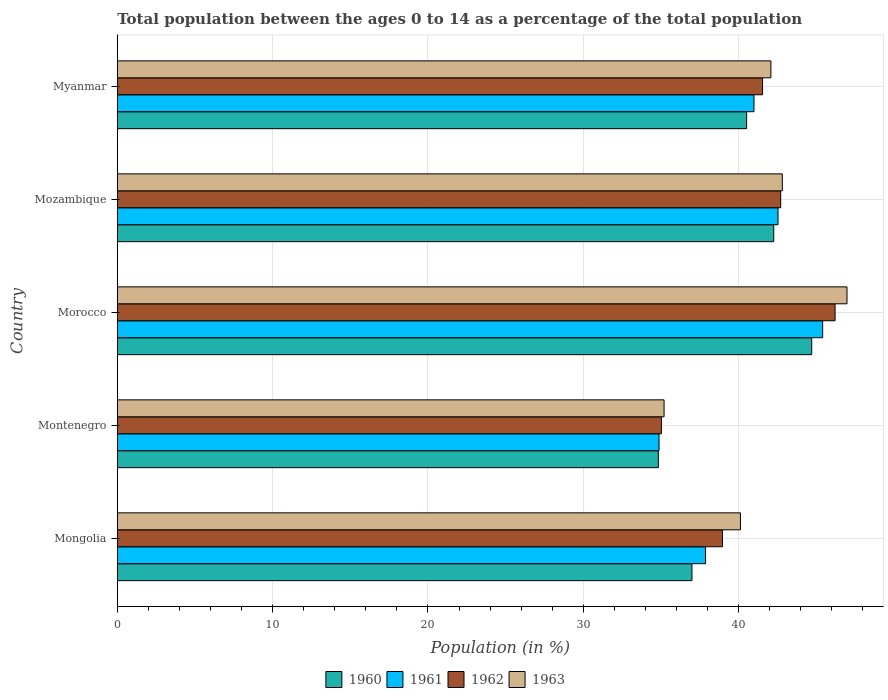How many different coloured bars are there?
Provide a short and direct response. 4. Are the number of bars per tick equal to the number of legend labels?
Give a very brief answer. Yes. Are the number of bars on each tick of the Y-axis equal?
Provide a succinct answer. Yes. What is the label of the 3rd group of bars from the top?
Make the answer very short. Morocco. In how many cases, is the number of bars for a given country not equal to the number of legend labels?
Offer a very short reply. 0. What is the percentage of the population ages 0 to 14 in 1962 in Mozambique?
Your answer should be very brief. 42.71. Across all countries, what is the maximum percentage of the population ages 0 to 14 in 1960?
Your response must be concise. 44.71. Across all countries, what is the minimum percentage of the population ages 0 to 14 in 1961?
Ensure brevity in your answer.  34.88. In which country was the percentage of the population ages 0 to 14 in 1963 maximum?
Keep it short and to the point. Morocco. In which country was the percentage of the population ages 0 to 14 in 1963 minimum?
Your response must be concise. Montenegro. What is the total percentage of the population ages 0 to 14 in 1962 in the graph?
Provide a succinct answer. 204.45. What is the difference between the percentage of the population ages 0 to 14 in 1963 in Mongolia and that in Montenegro?
Your response must be concise. 4.92. What is the difference between the percentage of the population ages 0 to 14 in 1960 in Mozambique and the percentage of the population ages 0 to 14 in 1961 in Montenegro?
Offer a terse response. 7.38. What is the average percentage of the population ages 0 to 14 in 1960 per country?
Provide a succinct answer. 39.86. What is the difference between the percentage of the population ages 0 to 14 in 1963 and percentage of the population ages 0 to 14 in 1961 in Mozambique?
Provide a short and direct response. 0.28. What is the ratio of the percentage of the population ages 0 to 14 in 1963 in Morocco to that in Myanmar?
Provide a succinct answer. 1.12. Is the percentage of the population ages 0 to 14 in 1962 in Mongolia less than that in Montenegro?
Make the answer very short. No. Is the difference between the percentage of the population ages 0 to 14 in 1963 in Montenegro and Myanmar greater than the difference between the percentage of the population ages 0 to 14 in 1961 in Montenegro and Myanmar?
Provide a succinct answer. No. What is the difference between the highest and the second highest percentage of the population ages 0 to 14 in 1962?
Provide a short and direct response. 3.5. What is the difference between the highest and the lowest percentage of the population ages 0 to 14 in 1961?
Provide a succinct answer. 10.53. Is the sum of the percentage of the population ages 0 to 14 in 1962 in Mozambique and Myanmar greater than the maximum percentage of the population ages 0 to 14 in 1963 across all countries?
Your response must be concise. Yes. What does the 4th bar from the top in Mongolia represents?
Your response must be concise. 1960. Is it the case that in every country, the sum of the percentage of the population ages 0 to 14 in 1960 and percentage of the population ages 0 to 14 in 1962 is greater than the percentage of the population ages 0 to 14 in 1963?
Provide a succinct answer. Yes. How many countries are there in the graph?
Keep it short and to the point. 5. What is the difference between two consecutive major ticks on the X-axis?
Provide a short and direct response. 10. Are the values on the major ticks of X-axis written in scientific E-notation?
Offer a very short reply. No. Where does the legend appear in the graph?
Ensure brevity in your answer.  Bottom center. What is the title of the graph?
Your response must be concise. Total population between the ages 0 to 14 as a percentage of the total population. Does "1987" appear as one of the legend labels in the graph?
Keep it short and to the point. No. What is the label or title of the Y-axis?
Provide a short and direct response. Country. What is the Population (in %) in 1960 in Mongolia?
Your answer should be compact. 37. What is the Population (in %) in 1961 in Mongolia?
Give a very brief answer. 37.87. What is the Population (in %) in 1962 in Mongolia?
Make the answer very short. 38.96. What is the Population (in %) of 1963 in Mongolia?
Provide a short and direct response. 40.12. What is the Population (in %) in 1960 in Montenegro?
Offer a very short reply. 34.83. What is the Population (in %) of 1961 in Montenegro?
Ensure brevity in your answer.  34.88. What is the Population (in %) in 1962 in Montenegro?
Your answer should be compact. 35.03. What is the Population (in %) in 1963 in Montenegro?
Your answer should be very brief. 35.2. What is the Population (in %) of 1960 in Morocco?
Make the answer very short. 44.71. What is the Population (in %) in 1961 in Morocco?
Your response must be concise. 45.41. What is the Population (in %) of 1962 in Morocco?
Provide a succinct answer. 46.21. What is the Population (in %) in 1963 in Morocco?
Give a very brief answer. 46.98. What is the Population (in %) in 1960 in Mozambique?
Offer a very short reply. 42.26. What is the Population (in %) in 1961 in Mozambique?
Your answer should be compact. 42.53. What is the Population (in %) of 1962 in Mozambique?
Your response must be concise. 42.71. What is the Population (in %) of 1963 in Mozambique?
Give a very brief answer. 42.81. What is the Population (in %) in 1960 in Myanmar?
Provide a succinct answer. 40.52. What is the Population (in %) in 1961 in Myanmar?
Keep it short and to the point. 40.99. What is the Population (in %) in 1962 in Myanmar?
Offer a very short reply. 41.54. What is the Population (in %) of 1963 in Myanmar?
Your response must be concise. 42.08. Across all countries, what is the maximum Population (in %) of 1960?
Keep it short and to the point. 44.71. Across all countries, what is the maximum Population (in %) of 1961?
Provide a short and direct response. 45.41. Across all countries, what is the maximum Population (in %) in 1962?
Provide a succinct answer. 46.21. Across all countries, what is the maximum Population (in %) of 1963?
Your answer should be very brief. 46.98. Across all countries, what is the minimum Population (in %) in 1960?
Make the answer very short. 34.83. Across all countries, what is the minimum Population (in %) in 1961?
Ensure brevity in your answer.  34.88. Across all countries, what is the minimum Population (in %) of 1962?
Provide a succinct answer. 35.03. Across all countries, what is the minimum Population (in %) in 1963?
Provide a short and direct response. 35.2. What is the total Population (in %) of 1960 in the graph?
Make the answer very short. 199.31. What is the total Population (in %) of 1961 in the graph?
Offer a very short reply. 201.68. What is the total Population (in %) of 1962 in the graph?
Provide a short and direct response. 204.45. What is the total Population (in %) in 1963 in the graph?
Your answer should be compact. 207.19. What is the difference between the Population (in %) in 1960 in Mongolia and that in Montenegro?
Keep it short and to the point. 2.17. What is the difference between the Population (in %) in 1961 in Mongolia and that in Montenegro?
Provide a succinct answer. 2.99. What is the difference between the Population (in %) in 1962 in Mongolia and that in Montenegro?
Provide a succinct answer. 3.93. What is the difference between the Population (in %) in 1963 in Mongolia and that in Montenegro?
Make the answer very short. 4.92. What is the difference between the Population (in %) of 1960 in Mongolia and that in Morocco?
Your answer should be compact. -7.71. What is the difference between the Population (in %) in 1961 in Mongolia and that in Morocco?
Make the answer very short. -7.54. What is the difference between the Population (in %) in 1962 in Mongolia and that in Morocco?
Your answer should be compact. -7.25. What is the difference between the Population (in %) in 1963 in Mongolia and that in Morocco?
Provide a succinct answer. -6.86. What is the difference between the Population (in %) of 1960 in Mongolia and that in Mozambique?
Your answer should be compact. -5.26. What is the difference between the Population (in %) of 1961 in Mongolia and that in Mozambique?
Provide a short and direct response. -4.67. What is the difference between the Population (in %) of 1962 in Mongolia and that in Mozambique?
Provide a succinct answer. -3.75. What is the difference between the Population (in %) of 1963 in Mongolia and that in Mozambique?
Offer a very short reply. -2.7. What is the difference between the Population (in %) in 1960 in Mongolia and that in Myanmar?
Your answer should be compact. -3.52. What is the difference between the Population (in %) of 1961 in Mongolia and that in Myanmar?
Make the answer very short. -3.12. What is the difference between the Population (in %) in 1962 in Mongolia and that in Myanmar?
Keep it short and to the point. -2.58. What is the difference between the Population (in %) of 1963 in Mongolia and that in Myanmar?
Offer a terse response. -1.96. What is the difference between the Population (in %) of 1960 in Montenegro and that in Morocco?
Provide a short and direct response. -9.87. What is the difference between the Population (in %) in 1961 in Montenegro and that in Morocco?
Offer a terse response. -10.53. What is the difference between the Population (in %) in 1962 in Montenegro and that in Morocco?
Provide a succinct answer. -11.18. What is the difference between the Population (in %) in 1963 in Montenegro and that in Morocco?
Offer a terse response. -11.78. What is the difference between the Population (in %) in 1960 in Montenegro and that in Mozambique?
Give a very brief answer. -7.43. What is the difference between the Population (in %) of 1961 in Montenegro and that in Mozambique?
Your response must be concise. -7.66. What is the difference between the Population (in %) of 1962 in Montenegro and that in Mozambique?
Your answer should be very brief. -7.68. What is the difference between the Population (in %) of 1963 in Montenegro and that in Mozambique?
Make the answer very short. -7.61. What is the difference between the Population (in %) in 1960 in Montenegro and that in Myanmar?
Make the answer very short. -5.68. What is the difference between the Population (in %) in 1961 in Montenegro and that in Myanmar?
Your response must be concise. -6.11. What is the difference between the Population (in %) in 1962 in Montenegro and that in Myanmar?
Keep it short and to the point. -6.51. What is the difference between the Population (in %) in 1963 in Montenegro and that in Myanmar?
Your answer should be very brief. -6.88. What is the difference between the Population (in %) in 1960 in Morocco and that in Mozambique?
Offer a very short reply. 2.44. What is the difference between the Population (in %) of 1961 in Morocco and that in Mozambique?
Your answer should be compact. 2.88. What is the difference between the Population (in %) of 1962 in Morocco and that in Mozambique?
Your answer should be very brief. 3.5. What is the difference between the Population (in %) of 1963 in Morocco and that in Mozambique?
Offer a terse response. 4.16. What is the difference between the Population (in %) of 1960 in Morocco and that in Myanmar?
Keep it short and to the point. 4.19. What is the difference between the Population (in %) in 1961 in Morocco and that in Myanmar?
Give a very brief answer. 4.42. What is the difference between the Population (in %) of 1962 in Morocco and that in Myanmar?
Make the answer very short. 4.67. What is the difference between the Population (in %) in 1963 in Morocco and that in Myanmar?
Keep it short and to the point. 4.9. What is the difference between the Population (in %) in 1960 in Mozambique and that in Myanmar?
Ensure brevity in your answer.  1.75. What is the difference between the Population (in %) of 1961 in Mozambique and that in Myanmar?
Make the answer very short. 1.54. What is the difference between the Population (in %) of 1962 in Mozambique and that in Myanmar?
Your answer should be very brief. 1.17. What is the difference between the Population (in %) in 1963 in Mozambique and that in Myanmar?
Give a very brief answer. 0.74. What is the difference between the Population (in %) of 1960 in Mongolia and the Population (in %) of 1961 in Montenegro?
Your answer should be compact. 2.12. What is the difference between the Population (in %) of 1960 in Mongolia and the Population (in %) of 1962 in Montenegro?
Give a very brief answer. 1.97. What is the difference between the Population (in %) in 1960 in Mongolia and the Population (in %) in 1963 in Montenegro?
Make the answer very short. 1.8. What is the difference between the Population (in %) in 1961 in Mongolia and the Population (in %) in 1962 in Montenegro?
Your answer should be compact. 2.84. What is the difference between the Population (in %) in 1961 in Mongolia and the Population (in %) in 1963 in Montenegro?
Offer a very short reply. 2.67. What is the difference between the Population (in %) in 1962 in Mongolia and the Population (in %) in 1963 in Montenegro?
Your response must be concise. 3.76. What is the difference between the Population (in %) in 1960 in Mongolia and the Population (in %) in 1961 in Morocco?
Make the answer very short. -8.41. What is the difference between the Population (in %) of 1960 in Mongolia and the Population (in %) of 1962 in Morocco?
Offer a terse response. -9.21. What is the difference between the Population (in %) in 1960 in Mongolia and the Population (in %) in 1963 in Morocco?
Keep it short and to the point. -9.98. What is the difference between the Population (in %) in 1961 in Mongolia and the Population (in %) in 1962 in Morocco?
Your answer should be compact. -8.34. What is the difference between the Population (in %) in 1961 in Mongolia and the Population (in %) in 1963 in Morocco?
Ensure brevity in your answer.  -9.11. What is the difference between the Population (in %) in 1962 in Mongolia and the Population (in %) in 1963 in Morocco?
Make the answer very short. -8.02. What is the difference between the Population (in %) in 1960 in Mongolia and the Population (in %) in 1961 in Mozambique?
Ensure brevity in your answer.  -5.54. What is the difference between the Population (in %) in 1960 in Mongolia and the Population (in %) in 1962 in Mozambique?
Your answer should be compact. -5.71. What is the difference between the Population (in %) of 1960 in Mongolia and the Population (in %) of 1963 in Mozambique?
Offer a very short reply. -5.82. What is the difference between the Population (in %) in 1961 in Mongolia and the Population (in %) in 1962 in Mozambique?
Your answer should be very brief. -4.84. What is the difference between the Population (in %) in 1961 in Mongolia and the Population (in %) in 1963 in Mozambique?
Make the answer very short. -4.95. What is the difference between the Population (in %) of 1962 in Mongolia and the Population (in %) of 1963 in Mozambique?
Provide a short and direct response. -3.86. What is the difference between the Population (in %) of 1960 in Mongolia and the Population (in %) of 1961 in Myanmar?
Give a very brief answer. -3.99. What is the difference between the Population (in %) in 1960 in Mongolia and the Population (in %) in 1962 in Myanmar?
Offer a very short reply. -4.55. What is the difference between the Population (in %) of 1960 in Mongolia and the Population (in %) of 1963 in Myanmar?
Keep it short and to the point. -5.08. What is the difference between the Population (in %) of 1961 in Mongolia and the Population (in %) of 1962 in Myanmar?
Your answer should be very brief. -3.68. What is the difference between the Population (in %) in 1961 in Mongolia and the Population (in %) in 1963 in Myanmar?
Ensure brevity in your answer.  -4.21. What is the difference between the Population (in %) of 1962 in Mongolia and the Population (in %) of 1963 in Myanmar?
Give a very brief answer. -3.12. What is the difference between the Population (in %) in 1960 in Montenegro and the Population (in %) in 1961 in Morocco?
Your answer should be very brief. -10.58. What is the difference between the Population (in %) in 1960 in Montenegro and the Population (in %) in 1962 in Morocco?
Make the answer very short. -11.38. What is the difference between the Population (in %) of 1960 in Montenegro and the Population (in %) of 1963 in Morocco?
Your answer should be very brief. -12.15. What is the difference between the Population (in %) of 1961 in Montenegro and the Population (in %) of 1962 in Morocco?
Give a very brief answer. -11.33. What is the difference between the Population (in %) of 1961 in Montenegro and the Population (in %) of 1963 in Morocco?
Your answer should be compact. -12.1. What is the difference between the Population (in %) in 1962 in Montenegro and the Population (in %) in 1963 in Morocco?
Keep it short and to the point. -11.95. What is the difference between the Population (in %) in 1960 in Montenegro and the Population (in %) in 1961 in Mozambique?
Keep it short and to the point. -7.7. What is the difference between the Population (in %) in 1960 in Montenegro and the Population (in %) in 1962 in Mozambique?
Offer a very short reply. -7.88. What is the difference between the Population (in %) of 1960 in Montenegro and the Population (in %) of 1963 in Mozambique?
Ensure brevity in your answer.  -7.98. What is the difference between the Population (in %) in 1961 in Montenegro and the Population (in %) in 1962 in Mozambique?
Keep it short and to the point. -7.83. What is the difference between the Population (in %) in 1961 in Montenegro and the Population (in %) in 1963 in Mozambique?
Your answer should be compact. -7.94. What is the difference between the Population (in %) in 1962 in Montenegro and the Population (in %) in 1963 in Mozambique?
Your response must be concise. -7.78. What is the difference between the Population (in %) in 1960 in Montenegro and the Population (in %) in 1961 in Myanmar?
Make the answer very short. -6.16. What is the difference between the Population (in %) in 1960 in Montenegro and the Population (in %) in 1962 in Myanmar?
Offer a very short reply. -6.71. What is the difference between the Population (in %) in 1960 in Montenegro and the Population (in %) in 1963 in Myanmar?
Ensure brevity in your answer.  -7.25. What is the difference between the Population (in %) of 1961 in Montenegro and the Population (in %) of 1962 in Myanmar?
Keep it short and to the point. -6.67. What is the difference between the Population (in %) in 1961 in Montenegro and the Population (in %) in 1963 in Myanmar?
Offer a terse response. -7.2. What is the difference between the Population (in %) in 1962 in Montenegro and the Population (in %) in 1963 in Myanmar?
Provide a succinct answer. -7.05. What is the difference between the Population (in %) of 1960 in Morocco and the Population (in %) of 1961 in Mozambique?
Ensure brevity in your answer.  2.17. What is the difference between the Population (in %) in 1960 in Morocco and the Population (in %) in 1962 in Mozambique?
Make the answer very short. 2. What is the difference between the Population (in %) in 1960 in Morocco and the Population (in %) in 1963 in Mozambique?
Your answer should be compact. 1.89. What is the difference between the Population (in %) of 1961 in Morocco and the Population (in %) of 1962 in Mozambique?
Offer a very short reply. 2.7. What is the difference between the Population (in %) of 1961 in Morocco and the Population (in %) of 1963 in Mozambique?
Ensure brevity in your answer.  2.6. What is the difference between the Population (in %) in 1962 in Morocco and the Population (in %) in 1963 in Mozambique?
Ensure brevity in your answer.  3.4. What is the difference between the Population (in %) in 1960 in Morocco and the Population (in %) in 1961 in Myanmar?
Make the answer very short. 3.72. What is the difference between the Population (in %) in 1960 in Morocco and the Population (in %) in 1962 in Myanmar?
Make the answer very short. 3.16. What is the difference between the Population (in %) in 1960 in Morocco and the Population (in %) in 1963 in Myanmar?
Provide a short and direct response. 2.63. What is the difference between the Population (in %) of 1961 in Morocco and the Population (in %) of 1962 in Myanmar?
Provide a short and direct response. 3.87. What is the difference between the Population (in %) of 1961 in Morocco and the Population (in %) of 1963 in Myanmar?
Offer a terse response. 3.33. What is the difference between the Population (in %) in 1962 in Morocco and the Population (in %) in 1963 in Myanmar?
Your response must be concise. 4.13. What is the difference between the Population (in %) of 1960 in Mozambique and the Population (in %) of 1961 in Myanmar?
Make the answer very short. 1.27. What is the difference between the Population (in %) of 1960 in Mozambique and the Population (in %) of 1962 in Myanmar?
Provide a short and direct response. 0.72. What is the difference between the Population (in %) in 1960 in Mozambique and the Population (in %) in 1963 in Myanmar?
Ensure brevity in your answer.  0.18. What is the difference between the Population (in %) of 1961 in Mozambique and the Population (in %) of 1962 in Myanmar?
Offer a very short reply. 0.99. What is the difference between the Population (in %) of 1961 in Mozambique and the Population (in %) of 1963 in Myanmar?
Your answer should be very brief. 0.46. What is the difference between the Population (in %) of 1962 in Mozambique and the Population (in %) of 1963 in Myanmar?
Give a very brief answer. 0.63. What is the average Population (in %) in 1960 per country?
Your answer should be very brief. 39.86. What is the average Population (in %) in 1961 per country?
Ensure brevity in your answer.  40.34. What is the average Population (in %) of 1962 per country?
Your answer should be very brief. 40.89. What is the average Population (in %) of 1963 per country?
Keep it short and to the point. 41.44. What is the difference between the Population (in %) of 1960 and Population (in %) of 1961 in Mongolia?
Keep it short and to the point. -0.87. What is the difference between the Population (in %) of 1960 and Population (in %) of 1962 in Mongolia?
Provide a short and direct response. -1.96. What is the difference between the Population (in %) of 1960 and Population (in %) of 1963 in Mongolia?
Your response must be concise. -3.12. What is the difference between the Population (in %) in 1961 and Population (in %) in 1962 in Mongolia?
Offer a very short reply. -1.09. What is the difference between the Population (in %) of 1961 and Population (in %) of 1963 in Mongolia?
Keep it short and to the point. -2.25. What is the difference between the Population (in %) in 1962 and Population (in %) in 1963 in Mongolia?
Give a very brief answer. -1.16. What is the difference between the Population (in %) of 1960 and Population (in %) of 1961 in Montenegro?
Give a very brief answer. -0.05. What is the difference between the Population (in %) in 1960 and Population (in %) in 1962 in Montenegro?
Provide a short and direct response. -0.2. What is the difference between the Population (in %) of 1960 and Population (in %) of 1963 in Montenegro?
Provide a succinct answer. -0.37. What is the difference between the Population (in %) in 1961 and Population (in %) in 1962 in Montenegro?
Keep it short and to the point. -0.15. What is the difference between the Population (in %) in 1961 and Population (in %) in 1963 in Montenegro?
Provide a short and direct response. -0.32. What is the difference between the Population (in %) in 1962 and Population (in %) in 1963 in Montenegro?
Give a very brief answer. -0.17. What is the difference between the Population (in %) in 1960 and Population (in %) in 1961 in Morocco?
Provide a succinct answer. -0.71. What is the difference between the Population (in %) of 1960 and Population (in %) of 1962 in Morocco?
Your answer should be very brief. -1.5. What is the difference between the Population (in %) in 1960 and Population (in %) in 1963 in Morocco?
Your response must be concise. -2.27. What is the difference between the Population (in %) in 1961 and Population (in %) in 1962 in Morocco?
Your answer should be compact. -0.8. What is the difference between the Population (in %) in 1961 and Population (in %) in 1963 in Morocco?
Provide a short and direct response. -1.57. What is the difference between the Population (in %) in 1962 and Population (in %) in 1963 in Morocco?
Provide a short and direct response. -0.77. What is the difference between the Population (in %) of 1960 and Population (in %) of 1961 in Mozambique?
Provide a short and direct response. -0.27. What is the difference between the Population (in %) of 1960 and Population (in %) of 1962 in Mozambique?
Provide a short and direct response. -0.45. What is the difference between the Population (in %) in 1960 and Population (in %) in 1963 in Mozambique?
Make the answer very short. -0.55. What is the difference between the Population (in %) in 1961 and Population (in %) in 1962 in Mozambique?
Keep it short and to the point. -0.17. What is the difference between the Population (in %) in 1961 and Population (in %) in 1963 in Mozambique?
Provide a succinct answer. -0.28. What is the difference between the Population (in %) of 1962 and Population (in %) of 1963 in Mozambique?
Make the answer very short. -0.1. What is the difference between the Population (in %) of 1960 and Population (in %) of 1961 in Myanmar?
Give a very brief answer. -0.47. What is the difference between the Population (in %) in 1960 and Population (in %) in 1962 in Myanmar?
Make the answer very short. -1.03. What is the difference between the Population (in %) in 1960 and Population (in %) in 1963 in Myanmar?
Provide a succinct answer. -1.56. What is the difference between the Population (in %) in 1961 and Population (in %) in 1962 in Myanmar?
Ensure brevity in your answer.  -0.55. What is the difference between the Population (in %) in 1961 and Population (in %) in 1963 in Myanmar?
Provide a succinct answer. -1.09. What is the difference between the Population (in %) in 1962 and Population (in %) in 1963 in Myanmar?
Your response must be concise. -0.54. What is the ratio of the Population (in %) in 1960 in Mongolia to that in Montenegro?
Ensure brevity in your answer.  1.06. What is the ratio of the Population (in %) of 1961 in Mongolia to that in Montenegro?
Give a very brief answer. 1.09. What is the ratio of the Population (in %) of 1962 in Mongolia to that in Montenegro?
Keep it short and to the point. 1.11. What is the ratio of the Population (in %) in 1963 in Mongolia to that in Montenegro?
Your response must be concise. 1.14. What is the ratio of the Population (in %) of 1960 in Mongolia to that in Morocco?
Provide a succinct answer. 0.83. What is the ratio of the Population (in %) of 1961 in Mongolia to that in Morocco?
Provide a short and direct response. 0.83. What is the ratio of the Population (in %) of 1962 in Mongolia to that in Morocco?
Your answer should be very brief. 0.84. What is the ratio of the Population (in %) in 1963 in Mongolia to that in Morocco?
Offer a very short reply. 0.85. What is the ratio of the Population (in %) in 1960 in Mongolia to that in Mozambique?
Provide a succinct answer. 0.88. What is the ratio of the Population (in %) in 1961 in Mongolia to that in Mozambique?
Ensure brevity in your answer.  0.89. What is the ratio of the Population (in %) of 1962 in Mongolia to that in Mozambique?
Provide a succinct answer. 0.91. What is the ratio of the Population (in %) in 1963 in Mongolia to that in Mozambique?
Keep it short and to the point. 0.94. What is the ratio of the Population (in %) in 1960 in Mongolia to that in Myanmar?
Offer a very short reply. 0.91. What is the ratio of the Population (in %) in 1961 in Mongolia to that in Myanmar?
Make the answer very short. 0.92. What is the ratio of the Population (in %) in 1962 in Mongolia to that in Myanmar?
Keep it short and to the point. 0.94. What is the ratio of the Population (in %) of 1963 in Mongolia to that in Myanmar?
Give a very brief answer. 0.95. What is the ratio of the Population (in %) of 1960 in Montenegro to that in Morocco?
Offer a very short reply. 0.78. What is the ratio of the Population (in %) of 1961 in Montenegro to that in Morocco?
Provide a short and direct response. 0.77. What is the ratio of the Population (in %) of 1962 in Montenegro to that in Morocco?
Your answer should be very brief. 0.76. What is the ratio of the Population (in %) in 1963 in Montenegro to that in Morocco?
Offer a terse response. 0.75. What is the ratio of the Population (in %) in 1960 in Montenegro to that in Mozambique?
Provide a short and direct response. 0.82. What is the ratio of the Population (in %) of 1961 in Montenegro to that in Mozambique?
Provide a short and direct response. 0.82. What is the ratio of the Population (in %) in 1962 in Montenegro to that in Mozambique?
Your answer should be compact. 0.82. What is the ratio of the Population (in %) of 1963 in Montenegro to that in Mozambique?
Ensure brevity in your answer.  0.82. What is the ratio of the Population (in %) in 1960 in Montenegro to that in Myanmar?
Offer a very short reply. 0.86. What is the ratio of the Population (in %) in 1961 in Montenegro to that in Myanmar?
Your answer should be compact. 0.85. What is the ratio of the Population (in %) in 1962 in Montenegro to that in Myanmar?
Offer a very short reply. 0.84. What is the ratio of the Population (in %) in 1963 in Montenegro to that in Myanmar?
Provide a succinct answer. 0.84. What is the ratio of the Population (in %) of 1960 in Morocco to that in Mozambique?
Make the answer very short. 1.06. What is the ratio of the Population (in %) of 1961 in Morocco to that in Mozambique?
Provide a succinct answer. 1.07. What is the ratio of the Population (in %) of 1962 in Morocco to that in Mozambique?
Your answer should be very brief. 1.08. What is the ratio of the Population (in %) in 1963 in Morocco to that in Mozambique?
Keep it short and to the point. 1.1. What is the ratio of the Population (in %) of 1960 in Morocco to that in Myanmar?
Your response must be concise. 1.1. What is the ratio of the Population (in %) in 1961 in Morocco to that in Myanmar?
Keep it short and to the point. 1.11. What is the ratio of the Population (in %) in 1962 in Morocco to that in Myanmar?
Make the answer very short. 1.11. What is the ratio of the Population (in %) of 1963 in Morocco to that in Myanmar?
Your answer should be very brief. 1.12. What is the ratio of the Population (in %) of 1960 in Mozambique to that in Myanmar?
Ensure brevity in your answer.  1.04. What is the ratio of the Population (in %) in 1961 in Mozambique to that in Myanmar?
Keep it short and to the point. 1.04. What is the ratio of the Population (in %) in 1962 in Mozambique to that in Myanmar?
Make the answer very short. 1.03. What is the ratio of the Population (in %) of 1963 in Mozambique to that in Myanmar?
Your response must be concise. 1.02. What is the difference between the highest and the second highest Population (in %) in 1960?
Give a very brief answer. 2.44. What is the difference between the highest and the second highest Population (in %) in 1961?
Ensure brevity in your answer.  2.88. What is the difference between the highest and the second highest Population (in %) of 1962?
Provide a short and direct response. 3.5. What is the difference between the highest and the second highest Population (in %) of 1963?
Provide a short and direct response. 4.16. What is the difference between the highest and the lowest Population (in %) of 1960?
Offer a terse response. 9.87. What is the difference between the highest and the lowest Population (in %) of 1961?
Provide a short and direct response. 10.53. What is the difference between the highest and the lowest Population (in %) in 1962?
Make the answer very short. 11.18. What is the difference between the highest and the lowest Population (in %) of 1963?
Provide a short and direct response. 11.78. 